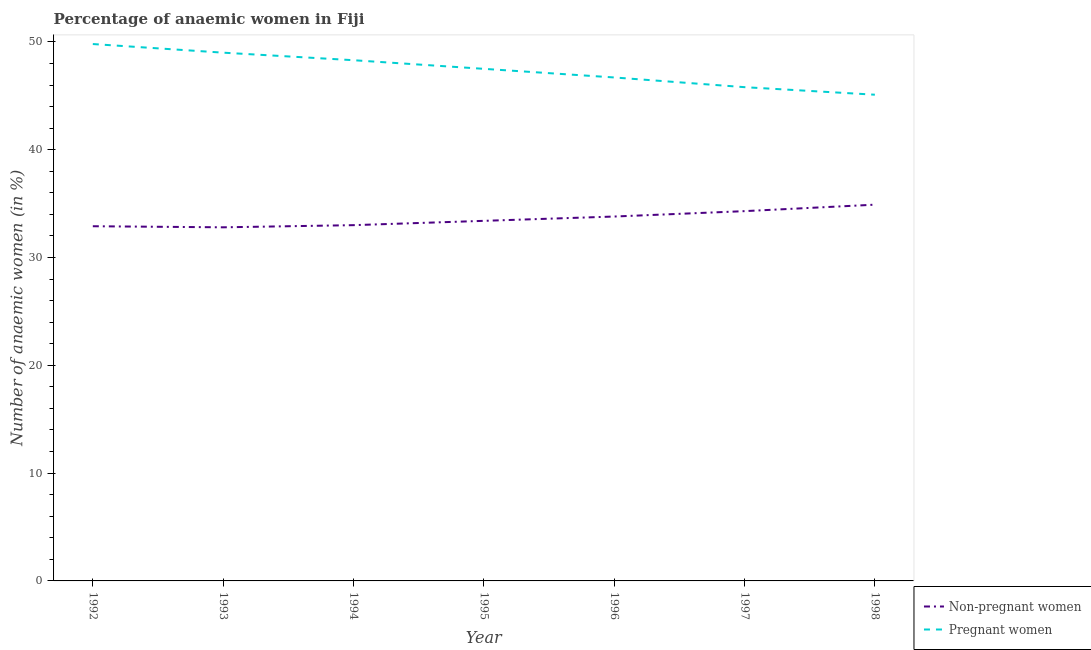Does the line corresponding to percentage of pregnant anaemic women intersect with the line corresponding to percentage of non-pregnant anaemic women?
Your response must be concise. No. What is the percentage of non-pregnant anaemic women in 1996?
Your answer should be compact. 33.8. Across all years, what is the maximum percentage of non-pregnant anaemic women?
Provide a short and direct response. 34.9. Across all years, what is the minimum percentage of pregnant anaemic women?
Provide a succinct answer. 45.1. What is the total percentage of pregnant anaemic women in the graph?
Give a very brief answer. 332.2. What is the difference between the percentage of pregnant anaemic women in 1992 and that in 1995?
Provide a succinct answer. 2.3. What is the difference between the percentage of non-pregnant anaemic women in 1997 and the percentage of pregnant anaemic women in 1995?
Ensure brevity in your answer.  -13.2. What is the average percentage of non-pregnant anaemic women per year?
Ensure brevity in your answer.  33.59. In the year 1993, what is the difference between the percentage of non-pregnant anaemic women and percentage of pregnant anaemic women?
Your answer should be very brief. -16.2. In how many years, is the percentage of non-pregnant anaemic women greater than 26 %?
Provide a succinct answer. 7. What is the ratio of the percentage of non-pregnant anaemic women in 1997 to that in 1998?
Make the answer very short. 0.98. Is the percentage of pregnant anaemic women in 1994 less than that in 1995?
Keep it short and to the point. No. Is the difference between the percentage of non-pregnant anaemic women in 1992 and 1997 greater than the difference between the percentage of pregnant anaemic women in 1992 and 1997?
Provide a succinct answer. No. What is the difference between the highest and the second highest percentage of non-pregnant anaemic women?
Give a very brief answer. 0.6. What is the difference between the highest and the lowest percentage of non-pregnant anaemic women?
Your answer should be compact. 2.1. In how many years, is the percentage of pregnant anaemic women greater than the average percentage of pregnant anaemic women taken over all years?
Your response must be concise. 4. Is the percentage of pregnant anaemic women strictly greater than the percentage of non-pregnant anaemic women over the years?
Keep it short and to the point. Yes. How many years are there in the graph?
Give a very brief answer. 7. Are the values on the major ticks of Y-axis written in scientific E-notation?
Make the answer very short. No. Does the graph contain any zero values?
Offer a terse response. No. Where does the legend appear in the graph?
Give a very brief answer. Bottom right. How many legend labels are there?
Offer a very short reply. 2. What is the title of the graph?
Give a very brief answer. Percentage of anaemic women in Fiji. Does "Female labor force" appear as one of the legend labels in the graph?
Your response must be concise. No. What is the label or title of the Y-axis?
Provide a short and direct response. Number of anaemic women (in %). What is the Number of anaemic women (in %) in Non-pregnant women in 1992?
Ensure brevity in your answer.  32.9. What is the Number of anaemic women (in %) in Pregnant women in 1992?
Give a very brief answer. 49.8. What is the Number of anaemic women (in %) of Non-pregnant women in 1993?
Provide a short and direct response. 32.8. What is the Number of anaemic women (in %) in Pregnant women in 1993?
Offer a terse response. 49. What is the Number of anaemic women (in %) in Non-pregnant women in 1994?
Offer a terse response. 33. What is the Number of anaemic women (in %) in Pregnant women in 1994?
Offer a very short reply. 48.3. What is the Number of anaemic women (in %) of Non-pregnant women in 1995?
Your answer should be compact. 33.4. What is the Number of anaemic women (in %) of Pregnant women in 1995?
Offer a terse response. 47.5. What is the Number of anaemic women (in %) in Non-pregnant women in 1996?
Keep it short and to the point. 33.8. What is the Number of anaemic women (in %) of Pregnant women in 1996?
Offer a terse response. 46.7. What is the Number of anaemic women (in %) of Non-pregnant women in 1997?
Your answer should be very brief. 34.3. What is the Number of anaemic women (in %) of Pregnant women in 1997?
Your answer should be compact. 45.8. What is the Number of anaemic women (in %) in Non-pregnant women in 1998?
Provide a succinct answer. 34.9. What is the Number of anaemic women (in %) of Pregnant women in 1998?
Your answer should be compact. 45.1. Across all years, what is the maximum Number of anaemic women (in %) of Non-pregnant women?
Provide a short and direct response. 34.9. Across all years, what is the maximum Number of anaemic women (in %) of Pregnant women?
Offer a very short reply. 49.8. Across all years, what is the minimum Number of anaemic women (in %) in Non-pregnant women?
Offer a terse response. 32.8. Across all years, what is the minimum Number of anaemic women (in %) of Pregnant women?
Provide a succinct answer. 45.1. What is the total Number of anaemic women (in %) of Non-pregnant women in the graph?
Provide a short and direct response. 235.1. What is the total Number of anaemic women (in %) of Pregnant women in the graph?
Offer a terse response. 332.2. What is the difference between the Number of anaemic women (in %) in Non-pregnant women in 1992 and that in 1994?
Your answer should be compact. -0.1. What is the difference between the Number of anaemic women (in %) of Pregnant women in 1992 and that in 1994?
Make the answer very short. 1.5. What is the difference between the Number of anaemic women (in %) in Non-pregnant women in 1992 and that in 1996?
Your answer should be compact. -0.9. What is the difference between the Number of anaemic women (in %) in Non-pregnant women in 1992 and that in 1997?
Your response must be concise. -1.4. What is the difference between the Number of anaemic women (in %) of Pregnant women in 1992 and that in 1998?
Keep it short and to the point. 4.7. What is the difference between the Number of anaemic women (in %) in Pregnant women in 1993 and that in 1994?
Your response must be concise. 0.7. What is the difference between the Number of anaemic women (in %) in Non-pregnant women in 1993 and that in 1995?
Offer a very short reply. -0.6. What is the difference between the Number of anaemic women (in %) in Pregnant women in 1993 and that in 1998?
Your response must be concise. 3.9. What is the difference between the Number of anaemic women (in %) of Non-pregnant women in 1994 and that in 1995?
Your response must be concise. -0.4. What is the difference between the Number of anaemic women (in %) in Pregnant women in 1994 and that in 1995?
Ensure brevity in your answer.  0.8. What is the difference between the Number of anaemic women (in %) in Non-pregnant women in 1994 and that in 1996?
Give a very brief answer. -0.8. What is the difference between the Number of anaemic women (in %) in Non-pregnant women in 1994 and that in 1998?
Your answer should be very brief. -1.9. What is the difference between the Number of anaemic women (in %) of Non-pregnant women in 1995 and that in 1997?
Provide a short and direct response. -0.9. What is the difference between the Number of anaemic women (in %) of Pregnant women in 1995 and that in 1997?
Your response must be concise. 1.7. What is the difference between the Number of anaemic women (in %) of Non-pregnant women in 1995 and that in 1998?
Your response must be concise. -1.5. What is the difference between the Number of anaemic women (in %) in Non-pregnant women in 1996 and that in 1997?
Your answer should be very brief. -0.5. What is the difference between the Number of anaemic women (in %) of Non-pregnant women in 1996 and that in 1998?
Offer a terse response. -1.1. What is the difference between the Number of anaemic women (in %) of Pregnant women in 1996 and that in 1998?
Provide a succinct answer. 1.6. What is the difference between the Number of anaemic women (in %) of Pregnant women in 1997 and that in 1998?
Offer a very short reply. 0.7. What is the difference between the Number of anaemic women (in %) in Non-pregnant women in 1992 and the Number of anaemic women (in %) in Pregnant women in 1993?
Offer a terse response. -16.1. What is the difference between the Number of anaemic women (in %) in Non-pregnant women in 1992 and the Number of anaemic women (in %) in Pregnant women in 1994?
Offer a very short reply. -15.4. What is the difference between the Number of anaemic women (in %) of Non-pregnant women in 1992 and the Number of anaemic women (in %) of Pregnant women in 1995?
Make the answer very short. -14.6. What is the difference between the Number of anaemic women (in %) of Non-pregnant women in 1993 and the Number of anaemic women (in %) of Pregnant women in 1994?
Make the answer very short. -15.5. What is the difference between the Number of anaemic women (in %) in Non-pregnant women in 1993 and the Number of anaemic women (in %) in Pregnant women in 1995?
Offer a terse response. -14.7. What is the difference between the Number of anaemic women (in %) in Non-pregnant women in 1993 and the Number of anaemic women (in %) in Pregnant women in 1997?
Make the answer very short. -13. What is the difference between the Number of anaemic women (in %) of Non-pregnant women in 1994 and the Number of anaemic women (in %) of Pregnant women in 1996?
Your answer should be very brief. -13.7. What is the difference between the Number of anaemic women (in %) in Non-pregnant women in 1994 and the Number of anaemic women (in %) in Pregnant women in 1997?
Your answer should be compact. -12.8. What is the difference between the Number of anaemic women (in %) of Non-pregnant women in 1995 and the Number of anaemic women (in %) of Pregnant women in 1996?
Your answer should be very brief. -13.3. What is the difference between the Number of anaemic women (in %) of Non-pregnant women in 1996 and the Number of anaemic women (in %) of Pregnant women in 1997?
Give a very brief answer. -12. What is the difference between the Number of anaemic women (in %) in Non-pregnant women in 1997 and the Number of anaemic women (in %) in Pregnant women in 1998?
Offer a very short reply. -10.8. What is the average Number of anaemic women (in %) in Non-pregnant women per year?
Ensure brevity in your answer.  33.59. What is the average Number of anaemic women (in %) in Pregnant women per year?
Your answer should be compact. 47.46. In the year 1992, what is the difference between the Number of anaemic women (in %) in Non-pregnant women and Number of anaemic women (in %) in Pregnant women?
Your answer should be very brief. -16.9. In the year 1993, what is the difference between the Number of anaemic women (in %) in Non-pregnant women and Number of anaemic women (in %) in Pregnant women?
Ensure brevity in your answer.  -16.2. In the year 1994, what is the difference between the Number of anaemic women (in %) of Non-pregnant women and Number of anaemic women (in %) of Pregnant women?
Your response must be concise. -15.3. In the year 1995, what is the difference between the Number of anaemic women (in %) of Non-pregnant women and Number of anaemic women (in %) of Pregnant women?
Your answer should be very brief. -14.1. In the year 1996, what is the difference between the Number of anaemic women (in %) in Non-pregnant women and Number of anaemic women (in %) in Pregnant women?
Keep it short and to the point. -12.9. In the year 1997, what is the difference between the Number of anaemic women (in %) of Non-pregnant women and Number of anaemic women (in %) of Pregnant women?
Keep it short and to the point. -11.5. In the year 1998, what is the difference between the Number of anaemic women (in %) in Non-pregnant women and Number of anaemic women (in %) in Pregnant women?
Your answer should be compact. -10.2. What is the ratio of the Number of anaemic women (in %) of Non-pregnant women in 1992 to that in 1993?
Your answer should be very brief. 1. What is the ratio of the Number of anaemic women (in %) of Pregnant women in 1992 to that in 1993?
Your response must be concise. 1.02. What is the ratio of the Number of anaemic women (in %) of Non-pregnant women in 1992 to that in 1994?
Your response must be concise. 1. What is the ratio of the Number of anaemic women (in %) in Pregnant women in 1992 to that in 1994?
Keep it short and to the point. 1.03. What is the ratio of the Number of anaemic women (in %) of Pregnant women in 1992 to that in 1995?
Your answer should be very brief. 1.05. What is the ratio of the Number of anaemic women (in %) in Non-pregnant women in 1992 to that in 1996?
Provide a succinct answer. 0.97. What is the ratio of the Number of anaemic women (in %) in Pregnant women in 1992 to that in 1996?
Keep it short and to the point. 1.07. What is the ratio of the Number of anaemic women (in %) of Non-pregnant women in 1992 to that in 1997?
Make the answer very short. 0.96. What is the ratio of the Number of anaemic women (in %) of Pregnant women in 1992 to that in 1997?
Provide a short and direct response. 1.09. What is the ratio of the Number of anaemic women (in %) of Non-pregnant women in 1992 to that in 1998?
Offer a very short reply. 0.94. What is the ratio of the Number of anaemic women (in %) in Pregnant women in 1992 to that in 1998?
Your answer should be compact. 1.1. What is the ratio of the Number of anaemic women (in %) of Non-pregnant women in 1993 to that in 1994?
Your response must be concise. 0.99. What is the ratio of the Number of anaemic women (in %) of Pregnant women in 1993 to that in 1994?
Provide a short and direct response. 1.01. What is the ratio of the Number of anaemic women (in %) of Non-pregnant women in 1993 to that in 1995?
Keep it short and to the point. 0.98. What is the ratio of the Number of anaemic women (in %) of Pregnant women in 1993 to that in 1995?
Keep it short and to the point. 1.03. What is the ratio of the Number of anaemic women (in %) of Non-pregnant women in 1993 to that in 1996?
Your answer should be compact. 0.97. What is the ratio of the Number of anaemic women (in %) of Pregnant women in 1993 to that in 1996?
Give a very brief answer. 1.05. What is the ratio of the Number of anaemic women (in %) of Non-pregnant women in 1993 to that in 1997?
Make the answer very short. 0.96. What is the ratio of the Number of anaemic women (in %) of Pregnant women in 1993 to that in 1997?
Offer a terse response. 1.07. What is the ratio of the Number of anaemic women (in %) of Non-pregnant women in 1993 to that in 1998?
Provide a succinct answer. 0.94. What is the ratio of the Number of anaemic women (in %) in Pregnant women in 1993 to that in 1998?
Ensure brevity in your answer.  1.09. What is the ratio of the Number of anaemic women (in %) in Pregnant women in 1994 to that in 1995?
Ensure brevity in your answer.  1.02. What is the ratio of the Number of anaemic women (in %) in Non-pregnant women in 1994 to that in 1996?
Make the answer very short. 0.98. What is the ratio of the Number of anaemic women (in %) in Pregnant women in 1994 to that in 1996?
Provide a succinct answer. 1.03. What is the ratio of the Number of anaemic women (in %) of Non-pregnant women in 1994 to that in 1997?
Ensure brevity in your answer.  0.96. What is the ratio of the Number of anaemic women (in %) in Pregnant women in 1994 to that in 1997?
Keep it short and to the point. 1.05. What is the ratio of the Number of anaemic women (in %) of Non-pregnant women in 1994 to that in 1998?
Keep it short and to the point. 0.95. What is the ratio of the Number of anaemic women (in %) of Pregnant women in 1994 to that in 1998?
Provide a succinct answer. 1.07. What is the ratio of the Number of anaemic women (in %) of Non-pregnant women in 1995 to that in 1996?
Give a very brief answer. 0.99. What is the ratio of the Number of anaemic women (in %) of Pregnant women in 1995 to that in 1996?
Your answer should be compact. 1.02. What is the ratio of the Number of anaemic women (in %) of Non-pregnant women in 1995 to that in 1997?
Your response must be concise. 0.97. What is the ratio of the Number of anaemic women (in %) of Pregnant women in 1995 to that in 1997?
Your answer should be compact. 1.04. What is the ratio of the Number of anaemic women (in %) in Pregnant women in 1995 to that in 1998?
Keep it short and to the point. 1.05. What is the ratio of the Number of anaemic women (in %) of Non-pregnant women in 1996 to that in 1997?
Provide a short and direct response. 0.99. What is the ratio of the Number of anaemic women (in %) of Pregnant women in 1996 to that in 1997?
Provide a short and direct response. 1.02. What is the ratio of the Number of anaemic women (in %) of Non-pregnant women in 1996 to that in 1998?
Provide a short and direct response. 0.97. What is the ratio of the Number of anaemic women (in %) of Pregnant women in 1996 to that in 1998?
Make the answer very short. 1.04. What is the ratio of the Number of anaemic women (in %) of Non-pregnant women in 1997 to that in 1998?
Your answer should be compact. 0.98. What is the ratio of the Number of anaemic women (in %) of Pregnant women in 1997 to that in 1998?
Give a very brief answer. 1.02. What is the difference between the highest and the second highest Number of anaemic women (in %) of Non-pregnant women?
Provide a short and direct response. 0.6. What is the difference between the highest and the lowest Number of anaemic women (in %) of Pregnant women?
Your answer should be compact. 4.7. 